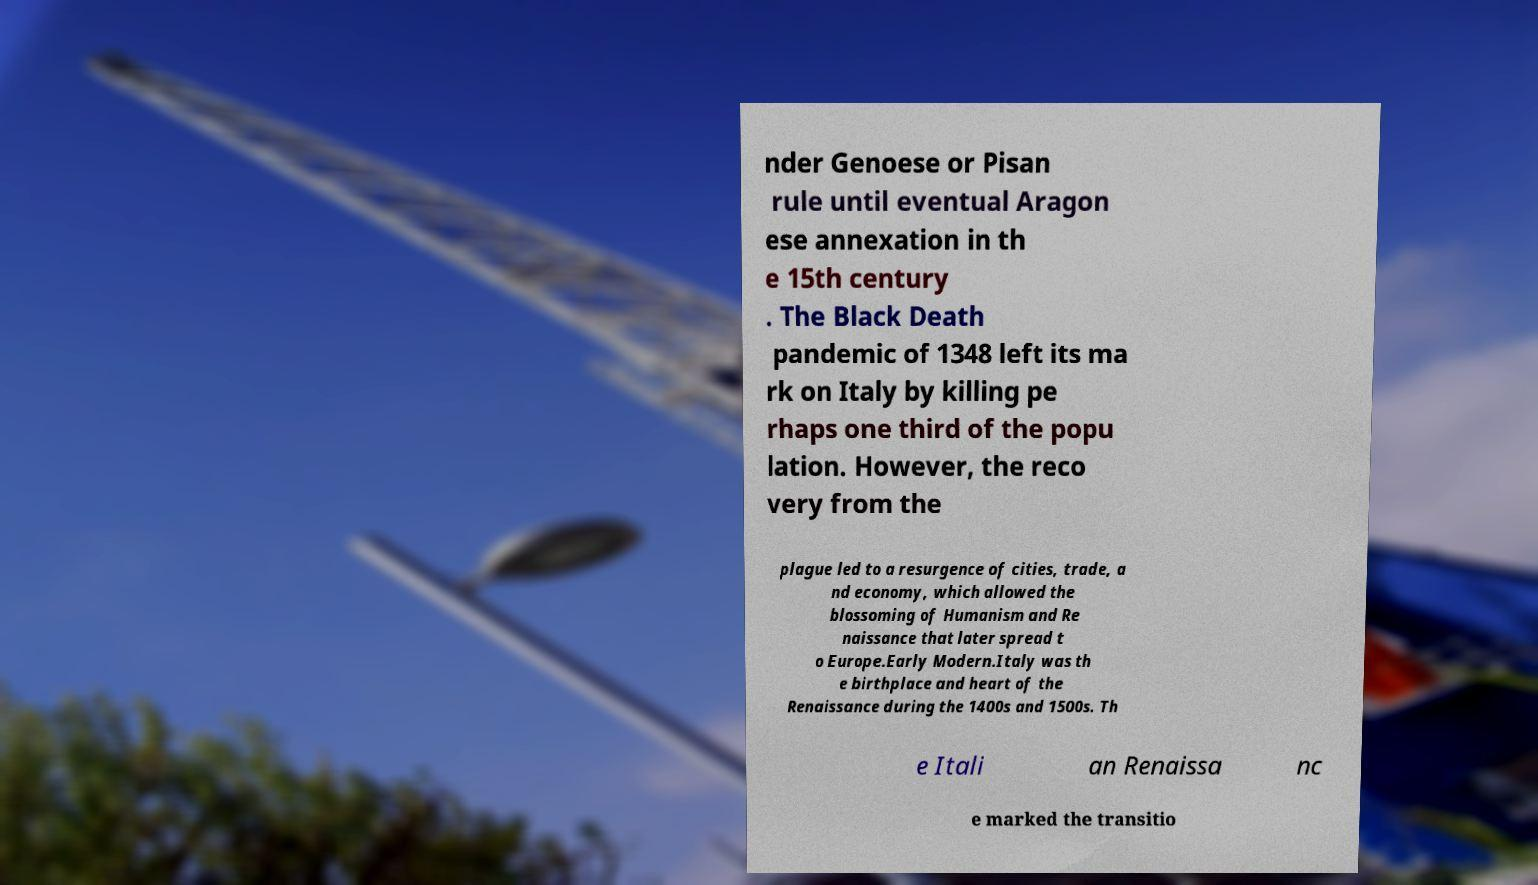Please read and relay the text visible in this image. What does it say? nder Genoese or Pisan rule until eventual Aragon ese annexation in th e 15th century . The Black Death pandemic of 1348 left its ma rk on Italy by killing pe rhaps one third of the popu lation. However, the reco very from the plague led to a resurgence of cities, trade, a nd economy, which allowed the blossoming of Humanism and Re naissance that later spread t o Europe.Early Modern.Italy was th e birthplace and heart of the Renaissance during the 1400s and 1500s. Th e Itali an Renaissa nc e marked the transitio 